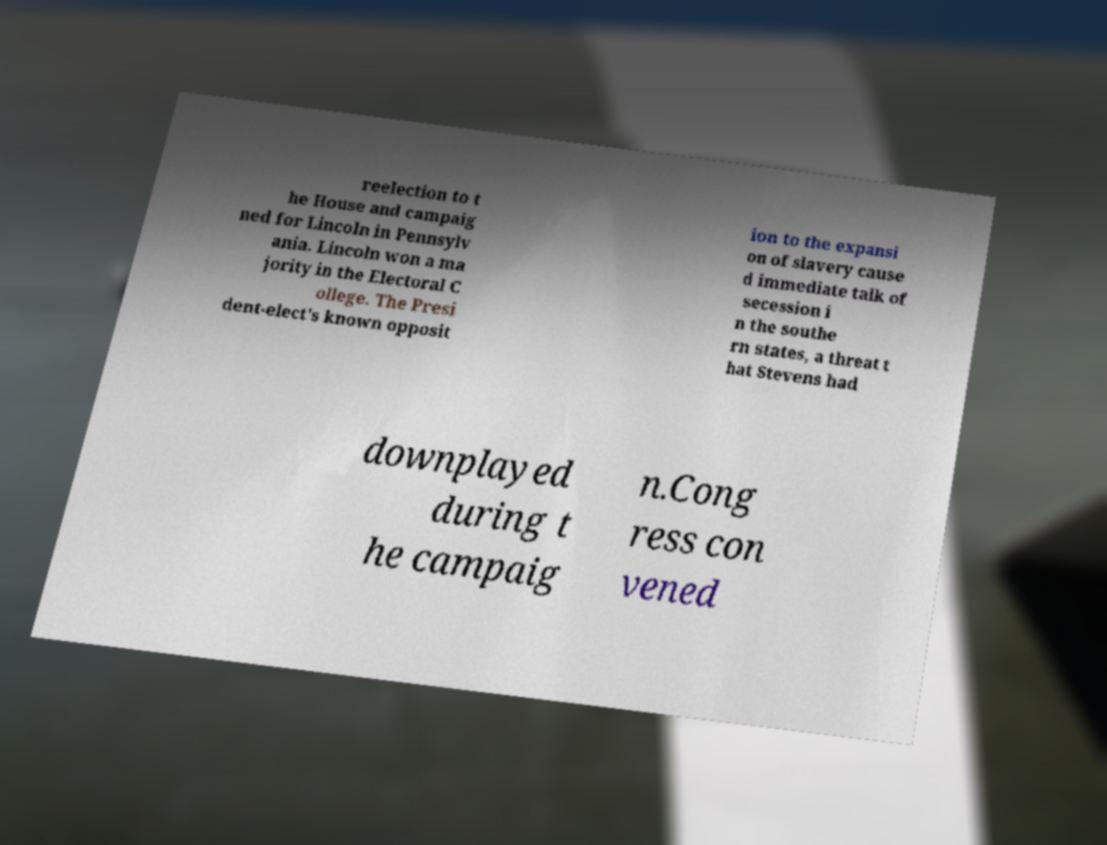There's text embedded in this image that I need extracted. Can you transcribe it verbatim? reelection to t he House and campaig ned for Lincoln in Pennsylv ania. Lincoln won a ma jority in the Electoral C ollege. The Presi dent-elect's known opposit ion to the expansi on of slavery cause d immediate talk of secession i n the southe rn states, a threat t hat Stevens had downplayed during t he campaig n.Cong ress con vened 